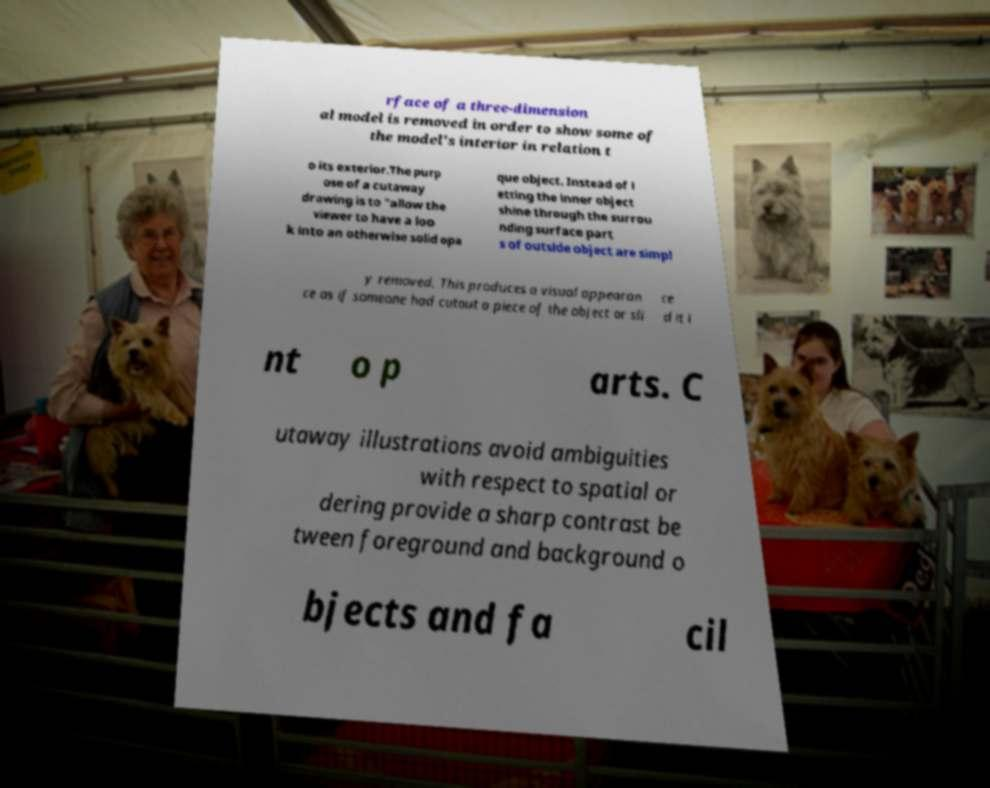Please read and relay the text visible in this image. What does it say? rface of a three-dimension al model is removed in order to show some of the model's interior in relation t o its exterior.The purp ose of a cutaway drawing is to "allow the viewer to have a loo k into an otherwise solid opa que object. Instead of l etting the inner object shine through the surrou nding surface part s of outside object are simpl y removed. This produces a visual appearan ce as if someone had cutout a piece of the object or sli ce d it i nt o p arts. C utaway illustrations avoid ambiguities with respect to spatial or dering provide a sharp contrast be tween foreground and background o bjects and fa cil 